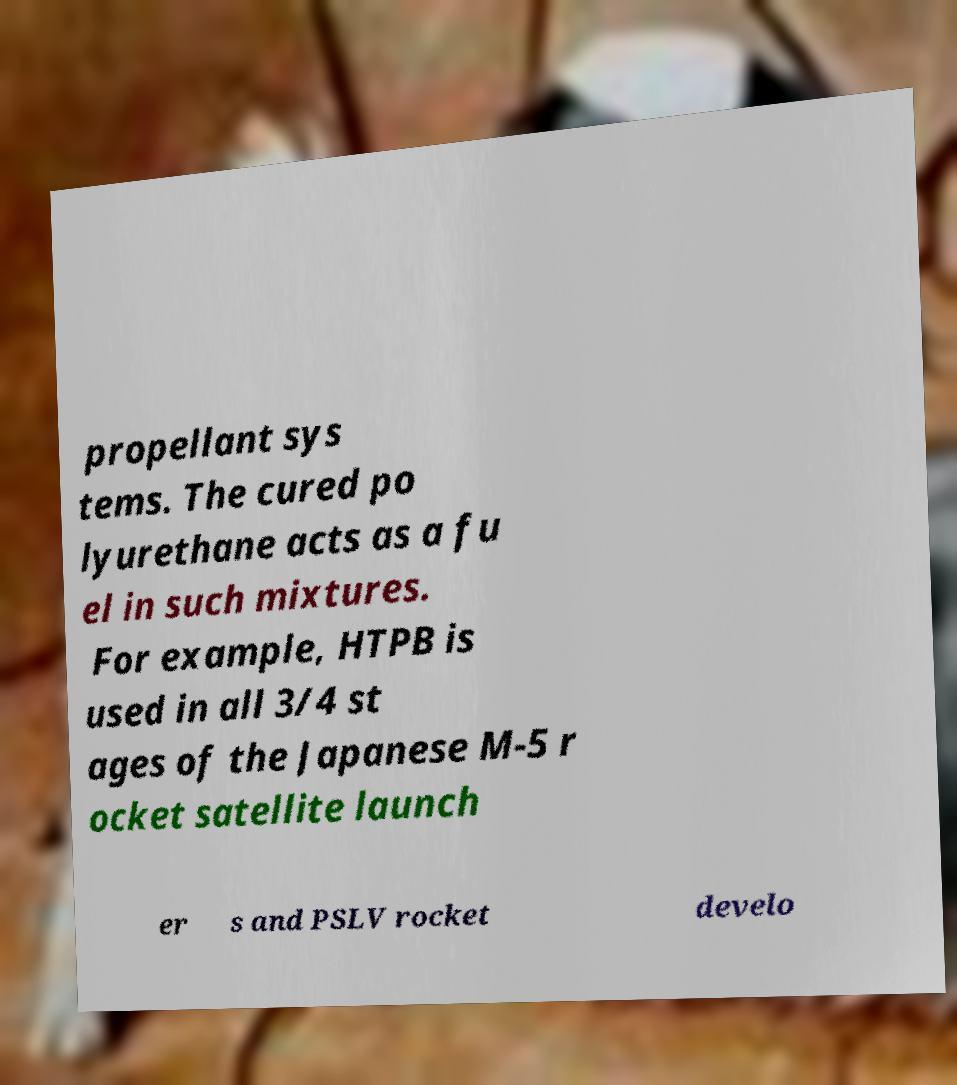Please read and relay the text visible in this image. What does it say? propellant sys tems. The cured po lyurethane acts as a fu el in such mixtures. For example, HTPB is used in all 3/4 st ages of the Japanese M-5 r ocket satellite launch er s and PSLV rocket develo 